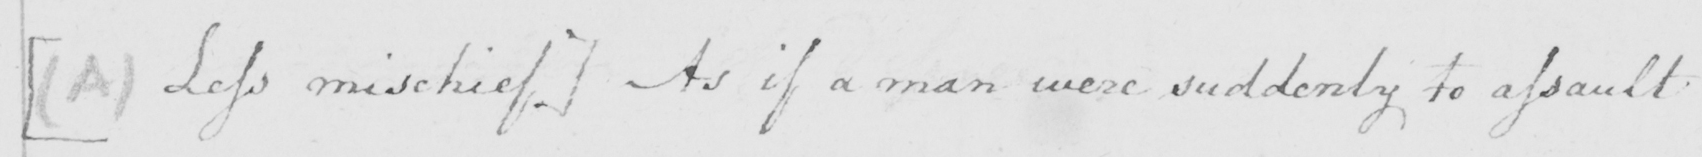Can you read and transcribe this handwriting? [(A) Les mischief] As if a man were suddenly to assault 